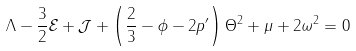Convert formula to latex. <formula><loc_0><loc_0><loc_500><loc_500>\Lambda - \frac { 3 } { 2 } \mathcal { E } + \mathcal { J } + \left ( \frac { 2 } { 3 } - \phi - 2 p ^ { \prime } \right ) \Theta ^ { 2 } + \mu + 2 \omega ^ { 2 } = 0</formula> 